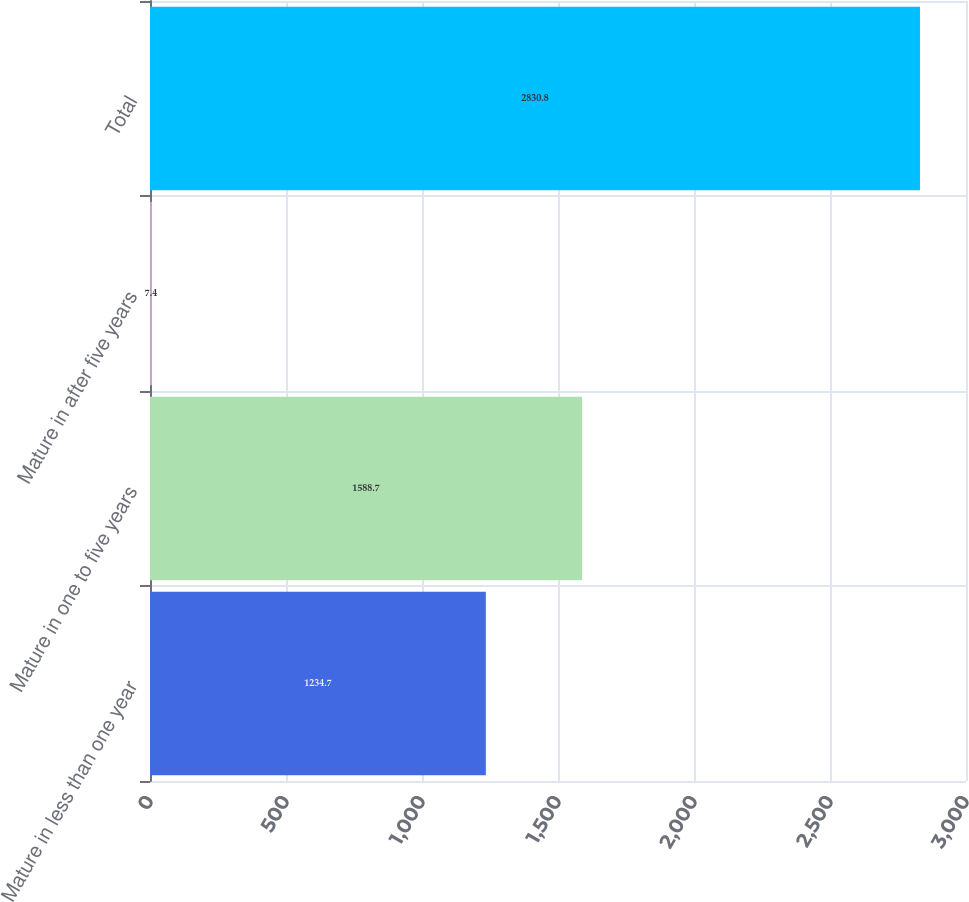Convert chart to OTSL. <chart><loc_0><loc_0><loc_500><loc_500><bar_chart><fcel>Mature in less than one year<fcel>Mature in one to five years<fcel>Mature in after five years<fcel>Total<nl><fcel>1234.7<fcel>1588.7<fcel>7.4<fcel>2830.8<nl></chart> 